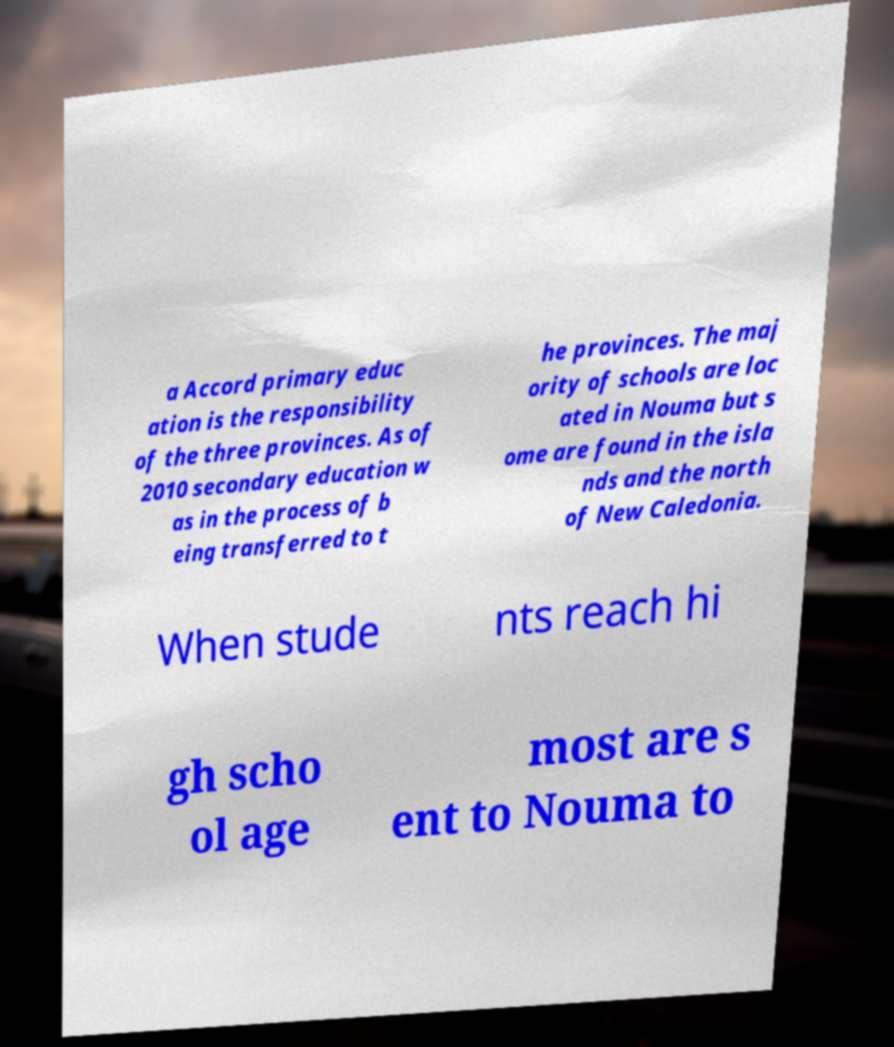Please read and relay the text visible in this image. What does it say? a Accord primary educ ation is the responsibility of the three provinces. As of 2010 secondary education w as in the process of b eing transferred to t he provinces. The maj ority of schools are loc ated in Nouma but s ome are found in the isla nds and the north of New Caledonia. When stude nts reach hi gh scho ol age most are s ent to Nouma to 